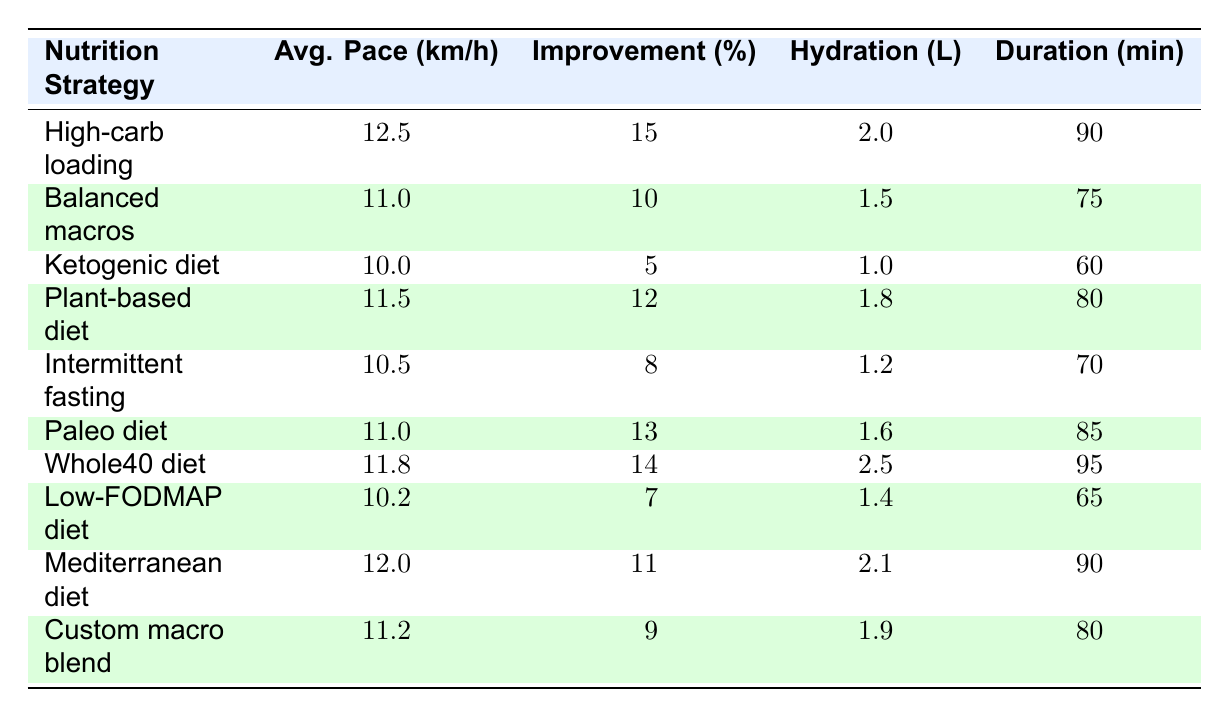What is the highest average pace among the nutrition strategies? By examining the table, “High-carb loading” has the highest average pace at 12.5 km/h.
Answer: 12.5 km/h Which nutrition strategy has the lowest performance improvement percentage? Looking at the data, "Ketogenic diet" has the lowest performance improvement at 5%.
Answer: 5% What is the average hydration intake across all strategies? Adding together all the hydration values (2.0 + 1.5 + 1.0 + 1.8 + 1.2 + 1.6 + 2.5 + 1.4 + 2.1 + 1.9) = 16.8 L, there are 10 values, so the average hydration intake is 16.8/10 = 1.68 L.
Answer: 1.68 L How many runners improved their performance by more than 12%? The strategies with improvements over 12% are "High-carb loading" (15%), "Plant-based diet" (12%), "Paleo diet" (13%), and "Whole40 diet" (14%), which amounts to 4 runners.
Answer: 4 Is the average pace of the "Paleo diet" higher than that of the "Balanced macros" strategy? "Paleo diet" has an average pace of 11.0 km/h, while "Balanced macros" has 11.0 km/h, thus they are equal, not higher.
Answer: No What combination of hydration intake and workout duration correlates with the highest performance improvement? The "High-carb loading" strategy shows a performance improvement of 15%, with 2.0 liters hydration and 90 minutes duration. This is the highest recorded.
Answer: 15% (High-carb loading) What is the difference in average pace between the "Whole40 diet" and the "Intermittent fasting"? The average pace of "Whole40 diet" is 11.8 km/h, and for "Intermittent fasting," it’s 10.5 km/h. The difference is 11.8 - 10.5 = 1.3 km/h.
Answer: 1.3 km/h Do runners following a plant-based diet tend to have higher hydration intake than those on a ketogenic diet? "Plant-based diet" runners have 1.8 liters of hydration while "Ketogenic diet" runners have only 1.0 liter, indicating that plant-based runners drink more.
Answer: Yes What is the median performance improvement percentage? The improvement percentages in order are: 5, 7, 8, 9, 10, 11, 12, 13, 14, 15. The median value, which is the average of 10 and 11, is (10 + 11) / 2 = 10.5%.
Answer: 10.5% Which runner had the longest workout duration and what was their nutrition strategy? "Ava Martinez" had a workout duration of 95 minutes with the "Whole40 diet" as the nutrition strategy.
Answer: Ava Martinez, Whole40 diet 